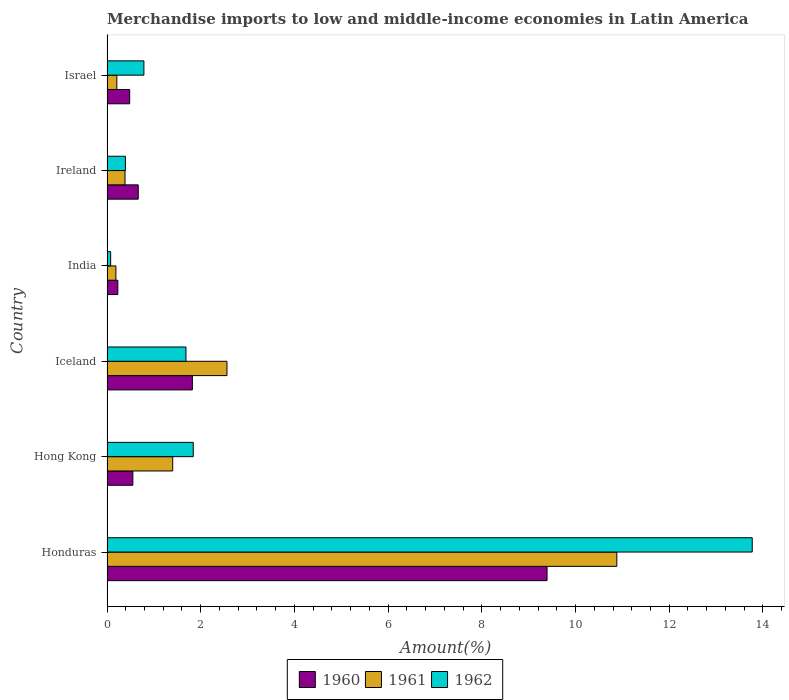Are the number of bars on each tick of the Y-axis equal?
Make the answer very short. Yes. How many bars are there on the 2nd tick from the top?
Offer a terse response. 3. What is the label of the 1st group of bars from the top?
Your answer should be very brief. Israel. In how many cases, is the number of bars for a given country not equal to the number of legend labels?
Your answer should be very brief. 0. What is the percentage of amount earned from merchandise imports in 1960 in Iceland?
Your answer should be compact. 1.82. Across all countries, what is the maximum percentage of amount earned from merchandise imports in 1961?
Your answer should be compact. 10.88. Across all countries, what is the minimum percentage of amount earned from merchandise imports in 1960?
Your answer should be compact. 0.23. In which country was the percentage of amount earned from merchandise imports in 1960 maximum?
Provide a succinct answer. Honduras. What is the total percentage of amount earned from merchandise imports in 1961 in the graph?
Provide a short and direct response. 15.63. What is the difference between the percentage of amount earned from merchandise imports in 1962 in Honduras and that in Iceland?
Keep it short and to the point. 12.09. What is the difference between the percentage of amount earned from merchandise imports in 1960 in Hong Kong and the percentage of amount earned from merchandise imports in 1962 in Ireland?
Make the answer very short. 0.16. What is the average percentage of amount earned from merchandise imports in 1962 per country?
Your answer should be very brief. 3.09. What is the difference between the percentage of amount earned from merchandise imports in 1961 and percentage of amount earned from merchandise imports in 1962 in India?
Your answer should be compact. 0.11. In how many countries, is the percentage of amount earned from merchandise imports in 1960 greater than 6 %?
Your answer should be compact. 1. What is the ratio of the percentage of amount earned from merchandise imports in 1962 in Honduras to that in Ireland?
Provide a short and direct response. 35.05. What is the difference between the highest and the second highest percentage of amount earned from merchandise imports in 1962?
Your response must be concise. 11.93. What is the difference between the highest and the lowest percentage of amount earned from merchandise imports in 1962?
Ensure brevity in your answer.  13.69. In how many countries, is the percentage of amount earned from merchandise imports in 1961 greater than the average percentage of amount earned from merchandise imports in 1961 taken over all countries?
Offer a very short reply. 1. Is the sum of the percentage of amount earned from merchandise imports in 1962 in Honduras and India greater than the maximum percentage of amount earned from merchandise imports in 1960 across all countries?
Your answer should be very brief. Yes. What does the 1st bar from the bottom in Iceland represents?
Offer a terse response. 1960. Is it the case that in every country, the sum of the percentage of amount earned from merchandise imports in 1961 and percentage of amount earned from merchandise imports in 1962 is greater than the percentage of amount earned from merchandise imports in 1960?
Offer a very short reply. Yes. How many bars are there?
Offer a very short reply. 18. Are all the bars in the graph horizontal?
Offer a terse response. Yes. What is the difference between two consecutive major ticks on the X-axis?
Your answer should be compact. 2. Does the graph contain any zero values?
Your response must be concise. No. Where does the legend appear in the graph?
Give a very brief answer. Bottom center. What is the title of the graph?
Your response must be concise. Merchandise imports to low and middle-income economies in Latin America. Does "2006" appear as one of the legend labels in the graph?
Offer a terse response. No. What is the label or title of the X-axis?
Your answer should be compact. Amount(%). What is the label or title of the Y-axis?
Ensure brevity in your answer.  Country. What is the Amount(%) in 1960 in Honduras?
Keep it short and to the point. 9.39. What is the Amount(%) of 1961 in Honduras?
Keep it short and to the point. 10.88. What is the Amount(%) of 1962 in Honduras?
Your answer should be very brief. 13.77. What is the Amount(%) of 1960 in Hong Kong?
Give a very brief answer. 0.55. What is the Amount(%) in 1961 in Hong Kong?
Ensure brevity in your answer.  1.4. What is the Amount(%) in 1962 in Hong Kong?
Your response must be concise. 1.84. What is the Amount(%) in 1960 in Iceland?
Your answer should be very brief. 1.82. What is the Amount(%) of 1961 in Iceland?
Your answer should be very brief. 2.56. What is the Amount(%) of 1962 in Iceland?
Provide a short and direct response. 1.69. What is the Amount(%) in 1960 in India?
Provide a short and direct response. 0.23. What is the Amount(%) of 1961 in India?
Your answer should be compact. 0.19. What is the Amount(%) of 1962 in India?
Ensure brevity in your answer.  0.08. What is the Amount(%) in 1960 in Ireland?
Keep it short and to the point. 0.67. What is the Amount(%) of 1961 in Ireland?
Provide a short and direct response. 0.38. What is the Amount(%) in 1962 in Ireland?
Keep it short and to the point. 0.39. What is the Amount(%) in 1960 in Israel?
Your answer should be compact. 0.48. What is the Amount(%) in 1961 in Israel?
Your answer should be compact. 0.21. What is the Amount(%) of 1962 in Israel?
Ensure brevity in your answer.  0.79. Across all countries, what is the maximum Amount(%) of 1960?
Provide a succinct answer. 9.39. Across all countries, what is the maximum Amount(%) in 1961?
Make the answer very short. 10.88. Across all countries, what is the maximum Amount(%) of 1962?
Offer a very short reply. 13.77. Across all countries, what is the minimum Amount(%) of 1960?
Offer a terse response. 0.23. Across all countries, what is the minimum Amount(%) in 1961?
Provide a succinct answer. 0.19. Across all countries, what is the minimum Amount(%) of 1962?
Ensure brevity in your answer.  0.08. What is the total Amount(%) in 1960 in the graph?
Ensure brevity in your answer.  13.15. What is the total Amount(%) in 1961 in the graph?
Ensure brevity in your answer.  15.63. What is the total Amount(%) of 1962 in the graph?
Offer a terse response. 18.56. What is the difference between the Amount(%) of 1960 in Honduras and that in Hong Kong?
Give a very brief answer. 8.84. What is the difference between the Amount(%) in 1961 in Honduras and that in Hong Kong?
Provide a succinct answer. 9.48. What is the difference between the Amount(%) of 1962 in Honduras and that in Hong Kong?
Provide a short and direct response. 11.93. What is the difference between the Amount(%) in 1960 in Honduras and that in Iceland?
Keep it short and to the point. 7.57. What is the difference between the Amount(%) in 1961 in Honduras and that in Iceland?
Your answer should be very brief. 8.32. What is the difference between the Amount(%) in 1962 in Honduras and that in Iceland?
Offer a terse response. 12.09. What is the difference between the Amount(%) of 1960 in Honduras and that in India?
Provide a succinct answer. 9.16. What is the difference between the Amount(%) of 1961 in Honduras and that in India?
Provide a succinct answer. 10.69. What is the difference between the Amount(%) in 1962 in Honduras and that in India?
Give a very brief answer. 13.69. What is the difference between the Amount(%) in 1960 in Honduras and that in Ireland?
Your answer should be compact. 8.73. What is the difference between the Amount(%) in 1961 in Honduras and that in Ireland?
Keep it short and to the point. 10.5. What is the difference between the Amount(%) of 1962 in Honduras and that in Ireland?
Provide a succinct answer. 13.38. What is the difference between the Amount(%) in 1960 in Honduras and that in Israel?
Your response must be concise. 8.91. What is the difference between the Amount(%) in 1961 in Honduras and that in Israel?
Make the answer very short. 10.67. What is the difference between the Amount(%) in 1962 in Honduras and that in Israel?
Provide a succinct answer. 12.98. What is the difference between the Amount(%) in 1960 in Hong Kong and that in Iceland?
Your response must be concise. -1.27. What is the difference between the Amount(%) of 1961 in Hong Kong and that in Iceland?
Offer a terse response. -1.16. What is the difference between the Amount(%) in 1962 in Hong Kong and that in Iceland?
Provide a succinct answer. 0.16. What is the difference between the Amount(%) in 1960 in Hong Kong and that in India?
Give a very brief answer. 0.32. What is the difference between the Amount(%) of 1961 in Hong Kong and that in India?
Offer a very short reply. 1.21. What is the difference between the Amount(%) of 1962 in Hong Kong and that in India?
Ensure brevity in your answer.  1.76. What is the difference between the Amount(%) in 1960 in Hong Kong and that in Ireland?
Provide a succinct answer. -0.12. What is the difference between the Amount(%) of 1961 in Hong Kong and that in Ireland?
Make the answer very short. 1.02. What is the difference between the Amount(%) of 1962 in Hong Kong and that in Ireland?
Keep it short and to the point. 1.45. What is the difference between the Amount(%) in 1960 in Hong Kong and that in Israel?
Provide a succinct answer. 0.07. What is the difference between the Amount(%) of 1961 in Hong Kong and that in Israel?
Your answer should be very brief. 1.19. What is the difference between the Amount(%) of 1962 in Hong Kong and that in Israel?
Provide a succinct answer. 1.05. What is the difference between the Amount(%) of 1960 in Iceland and that in India?
Give a very brief answer. 1.59. What is the difference between the Amount(%) of 1961 in Iceland and that in India?
Provide a succinct answer. 2.37. What is the difference between the Amount(%) in 1962 in Iceland and that in India?
Offer a very short reply. 1.61. What is the difference between the Amount(%) in 1960 in Iceland and that in Ireland?
Make the answer very short. 1.16. What is the difference between the Amount(%) in 1961 in Iceland and that in Ireland?
Give a very brief answer. 2.18. What is the difference between the Amount(%) in 1962 in Iceland and that in Ireland?
Your answer should be very brief. 1.29. What is the difference between the Amount(%) in 1960 in Iceland and that in Israel?
Make the answer very short. 1.34. What is the difference between the Amount(%) in 1961 in Iceland and that in Israel?
Keep it short and to the point. 2.35. What is the difference between the Amount(%) in 1962 in Iceland and that in Israel?
Your response must be concise. 0.9. What is the difference between the Amount(%) in 1960 in India and that in Ireland?
Keep it short and to the point. -0.44. What is the difference between the Amount(%) in 1961 in India and that in Ireland?
Ensure brevity in your answer.  -0.19. What is the difference between the Amount(%) in 1962 in India and that in Ireland?
Ensure brevity in your answer.  -0.32. What is the difference between the Amount(%) of 1960 in India and that in Israel?
Your response must be concise. -0.25. What is the difference between the Amount(%) in 1961 in India and that in Israel?
Your answer should be very brief. -0.02. What is the difference between the Amount(%) in 1962 in India and that in Israel?
Your answer should be very brief. -0.71. What is the difference between the Amount(%) in 1960 in Ireland and that in Israel?
Make the answer very short. 0.18. What is the difference between the Amount(%) in 1961 in Ireland and that in Israel?
Ensure brevity in your answer.  0.17. What is the difference between the Amount(%) in 1962 in Ireland and that in Israel?
Offer a terse response. -0.39. What is the difference between the Amount(%) of 1960 in Honduras and the Amount(%) of 1961 in Hong Kong?
Keep it short and to the point. 7.99. What is the difference between the Amount(%) of 1960 in Honduras and the Amount(%) of 1962 in Hong Kong?
Provide a succinct answer. 7.55. What is the difference between the Amount(%) of 1961 in Honduras and the Amount(%) of 1962 in Hong Kong?
Ensure brevity in your answer.  9.04. What is the difference between the Amount(%) in 1960 in Honduras and the Amount(%) in 1961 in Iceland?
Keep it short and to the point. 6.83. What is the difference between the Amount(%) in 1960 in Honduras and the Amount(%) in 1962 in Iceland?
Provide a succinct answer. 7.71. What is the difference between the Amount(%) in 1961 in Honduras and the Amount(%) in 1962 in Iceland?
Offer a very short reply. 9.2. What is the difference between the Amount(%) of 1960 in Honduras and the Amount(%) of 1961 in India?
Your answer should be compact. 9.2. What is the difference between the Amount(%) of 1960 in Honduras and the Amount(%) of 1962 in India?
Offer a very short reply. 9.31. What is the difference between the Amount(%) of 1961 in Honduras and the Amount(%) of 1962 in India?
Give a very brief answer. 10.8. What is the difference between the Amount(%) of 1960 in Honduras and the Amount(%) of 1961 in Ireland?
Keep it short and to the point. 9.01. What is the difference between the Amount(%) in 1960 in Honduras and the Amount(%) in 1962 in Ireland?
Offer a terse response. 9. What is the difference between the Amount(%) of 1961 in Honduras and the Amount(%) of 1962 in Ireland?
Provide a short and direct response. 10.49. What is the difference between the Amount(%) in 1960 in Honduras and the Amount(%) in 1961 in Israel?
Your response must be concise. 9.18. What is the difference between the Amount(%) in 1960 in Honduras and the Amount(%) in 1962 in Israel?
Offer a terse response. 8.6. What is the difference between the Amount(%) in 1961 in Honduras and the Amount(%) in 1962 in Israel?
Make the answer very short. 10.09. What is the difference between the Amount(%) in 1960 in Hong Kong and the Amount(%) in 1961 in Iceland?
Provide a short and direct response. -2.01. What is the difference between the Amount(%) of 1960 in Hong Kong and the Amount(%) of 1962 in Iceland?
Give a very brief answer. -1.13. What is the difference between the Amount(%) in 1961 in Hong Kong and the Amount(%) in 1962 in Iceland?
Provide a short and direct response. -0.28. What is the difference between the Amount(%) in 1960 in Hong Kong and the Amount(%) in 1961 in India?
Your response must be concise. 0.36. What is the difference between the Amount(%) of 1960 in Hong Kong and the Amount(%) of 1962 in India?
Your response must be concise. 0.47. What is the difference between the Amount(%) of 1961 in Hong Kong and the Amount(%) of 1962 in India?
Offer a very short reply. 1.32. What is the difference between the Amount(%) of 1960 in Hong Kong and the Amount(%) of 1961 in Ireland?
Offer a very short reply. 0.17. What is the difference between the Amount(%) of 1960 in Hong Kong and the Amount(%) of 1962 in Ireland?
Ensure brevity in your answer.  0.16. What is the difference between the Amount(%) in 1961 in Hong Kong and the Amount(%) in 1962 in Ireland?
Ensure brevity in your answer.  1.01. What is the difference between the Amount(%) in 1960 in Hong Kong and the Amount(%) in 1961 in Israel?
Keep it short and to the point. 0.34. What is the difference between the Amount(%) in 1960 in Hong Kong and the Amount(%) in 1962 in Israel?
Provide a succinct answer. -0.24. What is the difference between the Amount(%) of 1961 in Hong Kong and the Amount(%) of 1962 in Israel?
Offer a terse response. 0.61. What is the difference between the Amount(%) in 1960 in Iceland and the Amount(%) in 1961 in India?
Offer a terse response. 1.63. What is the difference between the Amount(%) of 1960 in Iceland and the Amount(%) of 1962 in India?
Provide a short and direct response. 1.74. What is the difference between the Amount(%) in 1961 in Iceland and the Amount(%) in 1962 in India?
Offer a very short reply. 2.48. What is the difference between the Amount(%) of 1960 in Iceland and the Amount(%) of 1961 in Ireland?
Keep it short and to the point. 1.44. What is the difference between the Amount(%) of 1960 in Iceland and the Amount(%) of 1962 in Ireland?
Provide a succinct answer. 1.43. What is the difference between the Amount(%) of 1961 in Iceland and the Amount(%) of 1962 in Ireland?
Your answer should be compact. 2.17. What is the difference between the Amount(%) in 1960 in Iceland and the Amount(%) in 1961 in Israel?
Provide a succinct answer. 1.61. What is the difference between the Amount(%) in 1960 in Iceland and the Amount(%) in 1962 in Israel?
Give a very brief answer. 1.03. What is the difference between the Amount(%) in 1961 in Iceland and the Amount(%) in 1962 in Israel?
Your answer should be very brief. 1.77. What is the difference between the Amount(%) in 1960 in India and the Amount(%) in 1961 in Ireland?
Provide a short and direct response. -0.15. What is the difference between the Amount(%) of 1960 in India and the Amount(%) of 1962 in Ireland?
Provide a succinct answer. -0.16. What is the difference between the Amount(%) in 1961 in India and the Amount(%) in 1962 in Ireland?
Provide a succinct answer. -0.2. What is the difference between the Amount(%) in 1960 in India and the Amount(%) in 1961 in Israel?
Provide a short and direct response. 0.02. What is the difference between the Amount(%) in 1960 in India and the Amount(%) in 1962 in Israel?
Your response must be concise. -0.56. What is the difference between the Amount(%) of 1961 in India and the Amount(%) of 1962 in Israel?
Offer a very short reply. -0.6. What is the difference between the Amount(%) in 1960 in Ireland and the Amount(%) in 1961 in Israel?
Make the answer very short. 0.46. What is the difference between the Amount(%) in 1960 in Ireland and the Amount(%) in 1962 in Israel?
Your answer should be very brief. -0.12. What is the difference between the Amount(%) in 1961 in Ireland and the Amount(%) in 1962 in Israel?
Keep it short and to the point. -0.4. What is the average Amount(%) in 1960 per country?
Your response must be concise. 2.19. What is the average Amount(%) in 1961 per country?
Offer a very short reply. 2.6. What is the average Amount(%) of 1962 per country?
Provide a short and direct response. 3.09. What is the difference between the Amount(%) in 1960 and Amount(%) in 1961 in Honduras?
Offer a terse response. -1.49. What is the difference between the Amount(%) in 1960 and Amount(%) in 1962 in Honduras?
Keep it short and to the point. -4.38. What is the difference between the Amount(%) in 1961 and Amount(%) in 1962 in Honduras?
Offer a very short reply. -2.89. What is the difference between the Amount(%) in 1960 and Amount(%) in 1961 in Hong Kong?
Your answer should be very brief. -0.85. What is the difference between the Amount(%) of 1960 and Amount(%) of 1962 in Hong Kong?
Provide a short and direct response. -1.29. What is the difference between the Amount(%) of 1961 and Amount(%) of 1962 in Hong Kong?
Give a very brief answer. -0.44. What is the difference between the Amount(%) in 1960 and Amount(%) in 1961 in Iceland?
Keep it short and to the point. -0.74. What is the difference between the Amount(%) of 1960 and Amount(%) of 1962 in Iceland?
Offer a very short reply. 0.14. What is the difference between the Amount(%) of 1961 and Amount(%) of 1962 in Iceland?
Make the answer very short. 0.88. What is the difference between the Amount(%) in 1960 and Amount(%) in 1961 in India?
Make the answer very short. 0.04. What is the difference between the Amount(%) of 1960 and Amount(%) of 1962 in India?
Keep it short and to the point. 0.15. What is the difference between the Amount(%) in 1961 and Amount(%) in 1962 in India?
Provide a succinct answer. 0.11. What is the difference between the Amount(%) of 1960 and Amount(%) of 1961 in Ireland?
Make the answer very short. 0.28. What is the difference between the Amount(%) of 1960 and Amount(%) of 1962 in Ireland?
Your answer should be very brief. 0.27. What is the difference between the Amount(%) in 1961 and Amount(%) in 1962 in Ireland?
Provide a succinct answer. -0.01. What is the difference between the Amount(%) in 1960 and Amount(%) in 1961 in Israel?
Provide a short and direct response. 0.27. What is the difference between the Amount(%) in 1960 and Amount(%) in 1962 in Israel?
Your answer should be very brief. -0.3. What is the difference between the Amount(%) of 1961 and Amount(%) of 1962 in Israel?
Ensure brevity in your answer.  -0.58. What is the ratio of the Amount(%) in 1960 in Honduras to that in Hong Kong?
Ensure brevity in your answer.  17.03. What is the ratio of the Amount(%) in 1961 in Honduras to that in Hong Kong?
Provide a succinct answer. 7.76. What is the ratio of the Amount(%) in 1962 in Honduras to that in Hong Kong?
Provide a succinct answer. 7.48. What is the ratio of the Amount(%) in 1960 in Honduras to that in Iceland?
Ensure brevity in your answer.  5.15. What is the ratio of the Amount(%) in 1961 in Honduras to that in Iceland?
Give a very brief answer. 4.25. What is the ratio of the Amount(%) in 1962 in Honduras to that in Iceland?
Ensure brevity in your answer.  8.17. What is the ratio of the Amount(%) of 1960 in Honduras to that in India?
Offer a very short reply. 40.63. What is the ratio of the Amount(%) in 1961 in Honduras to that in India?
Keep it short and to the point. 57.34. What is the ratio of the Amount(%) in 1962 in Honduras to that in India?
Provide a succinct answer. 176.83. What is the ratio of the Amount(%) of 1960 in Honduras to that in Ireland?
Your answer should be very brief. 14.09. What is the ratio of the Amount(%) of 1961 in Honduras to that in Ireland?
Your response must be concise. 28.32. What is the ratio of the Amount(%) in 1962 in Honduras to that in Ireland?
Ensure brevity in your answer.  35.05. What is the ratio of the Amount(%) in 1960 in Honduras to that in Israel?
Provide a short and direct response. 19.41. What is the ratio of the Amount(%) of 1961 in Honduras to that in Israel?
Your response must be concise. 51.9. What is the ratio of the Amount(%) of 1962 in Honduras to that in Israel?
Your answer should be compact. 17.49. What is the ratio of the Amount(%) in 1960 in Hong Kong to that in Iceland?
Give a very brief answer. 0.3. What is the ratio of the Amount(%) of 1961 in Hong Kong to that in Iceland?
Keep it short and to the point. 0.55. What is the ratio of the Amount(%) in 1962 in Hong Kong to that in Iceland?
Make the answer very short. 1.09. What is the ratio of the Amount(%) of 1960 in Hong Kong to that in India?
Make the answer very short. 2.39. What is the ratio of the Amount(%) of 1961 in Hong Kong to that in India?
Ensure brevity in your answer.  7.39. What is the ratio of the Amount(%) in 1962 in Hong Kong to that in India?
Make the answer very short. 23.64. What is the ratio of the Amount(%) of 1960 in Hong Kong to that in Ireland?
Offer a very short reply. 0.83. What is the ratio of the Amount(%) in 1961 in Hong Kong to that in Ireland?
Your response must be concise. 3.65. What is the ratio of the Amount(%) in 1962 in Hong Kong to that in Ireland?
Your response must be concise. 4.69. What is the ratio of the Amount(%) in 1960 in Hong Kong to that in Israel?
Ensure brevity in your answer.  1.14. What is the ratio of the Amount(%) of 1961 in Hong Kong to that in Israel?
Your answer should be very brief. 6.69. What is the ratio of the Amount(%) in 1962 in Hong Kong to that in Israel?
Provide a short and direct response. 2.34. What is the ratio of the Amount(%) of 1960 in Iceland to that in India?
Your response must be concise. 7.88. What is the ratio of the Amount(%) of 1961 in Iceland to that in India?
Keep it short and to the point. 13.49. What is the ratio of the Amount(%) of 1962 in Iceland to that in India?
Give a very brief answer. 21.64. What is the ratio of the Amount(%) of 1960 in Iceland to that in Ireland?
Provide a succinct answer. 2.73. What is the ratio of the Amount(%) in 1961 in Iceland to that in Ireland?
Give a very brief answer. 6.67. What is the ratio of the Amount(%) of 1962 in Iceland to that in Ireland?
Keep it short and to the point. 4.29. What is the ratio of the Amount(%) of 1960 in Iceland to that in Israel?
Your answer should be compact. 3.77. What is the ratio of the Amount(%) in 1961 in Iceland to that in Israel?
Keep it short and to the point. 12.21. What is the ratio of the Amount(%) of 1962 in Iceland to that in Israel?
Your answer should be compact. 2.14. What is the ratio of the Amount(%) in 1960 in India to that in Ireland?
Give a very brief answer. 0.35. What is the ratio of the Amount(%) in 1961 in India to that in Ireland?
Your response must be concise. 0.49. What is the ratio of the Amount(%) in 1962 in India to that in Ireland?
Give a very brief answer. 0.2. What is the ratio of the Amount(%) of 1960 in India to that in Israel?
Offer a very short reply. 0.48. What is the ratio of the Amount(%) in 1961 in India to that in Israel?
Offer a terse response. 0.91. What is the ratio of the Amount(%) of 1962 in India to that in Israel?
Offer a very short reply. 0.1. What is the ratio of the Amount(%) of 1960 in Ireland to that in Israel?
Your answer should be very brief. 1.38. What is the ratio of the Amount(%) of 1961 in Ireland to that in Israel?
Provide a succinct answer. 1.83. What is the ratio of the Amount(%) of 1962 in Ireland to that in Israel?
Make the answer very short. 0.5. What is the difference between the highest and the second highest Amount(%) in 1960?
Make the answer very short. 7.57. What is the difference between the highest and the second highest Amount(%) of 1961?
Keep it short and to the point. 8.32. What is the difference between the highest and the second highest Amount(%) in 1962?
Give a very brief answer. 11.93. What is the difference between the highest and the lowest Amount(%) of 1960?
Ensure brevity in your answer.  9.16. What is the difference between the highest and the lowest Amount(%) in 1961?
Give a very brief answer. 10.69. What is the difference between the highest and the lowest Amount(%) of 1962?
Offer a very short reply. 13.69. 